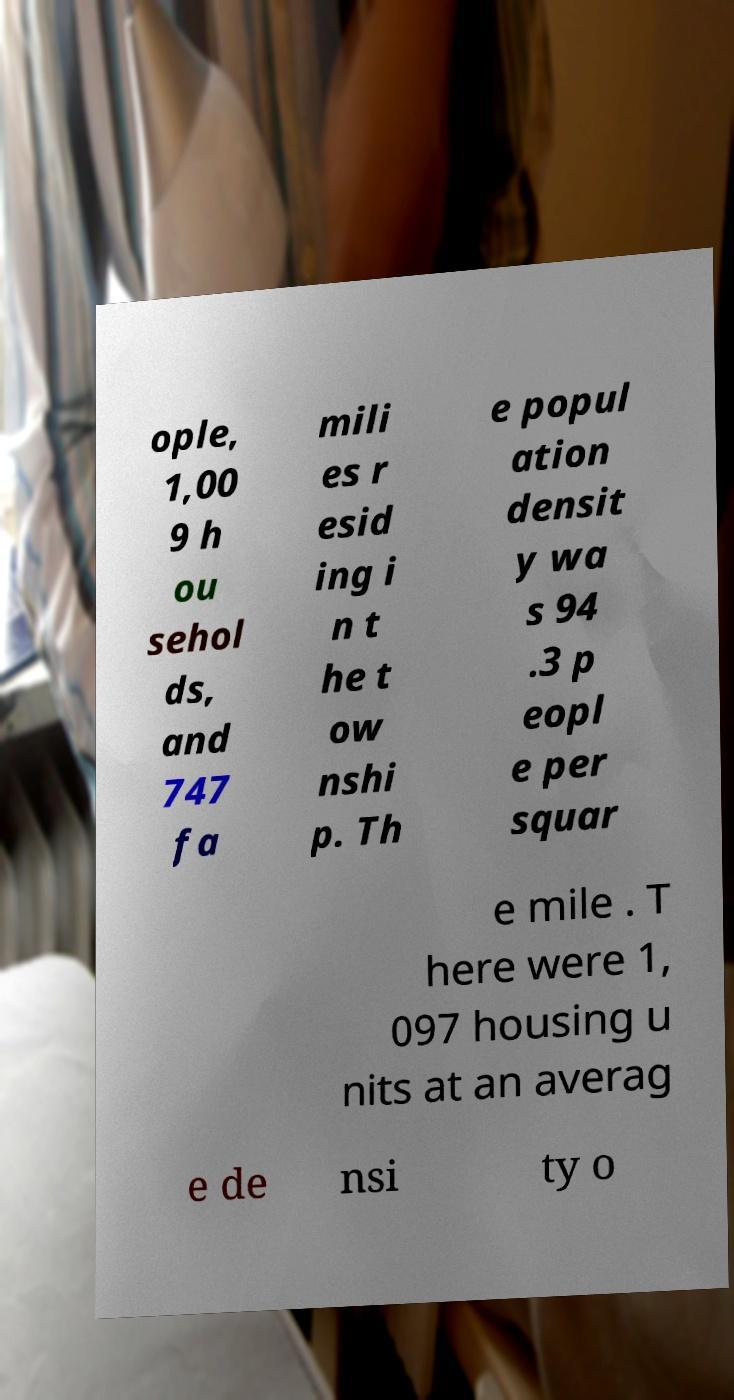For documentation purposes, I need the text within this image transcribed. Could you provide that? ople, 1,00 9 h ou sehol ds, and 747 fa mili es r esid ing i n t he t ow nshi p. Th e popul ation densit y wa s 94 .3 p eopl e per squar e mile . T here were 1, 097 housing u nits at an averag e de nsi ty o 